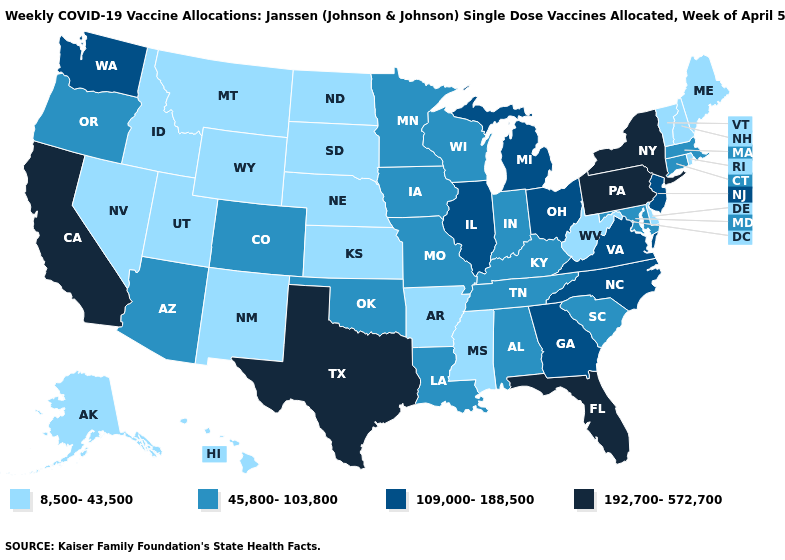Does Oklahoma have the same value as Minnesota?
Concise answer only. Yes. Name the states that have a value in the range 45,800-103,800?
Be succinct. Alabama, Arizona, Colorado, Connecticut, Indiana, Iowa, Kentucky, Louisiana, Maryland, Massachusetts, Minnesota, Missouri, Oklahoma, Oregon, South Carolina, Tennessee, Wisconsin. Among the states that border Arkansas , does Mississippi have the highest value?
Be succinct. No. Name the states that have a value in the range 8,500-43,500?
Answer briefly. Alaska, Arkansas, Delaware, Hawaii, Idaho, Kansas, Maine, Mississippi, Montana, Nebraska, Nevada, New Hampshire, New Mexico, North Dakota, Rhode Island, South Dakota, Utah, Vermont, West Virginia, Wyoming. What is the value of South Carolina?
Answer briefly. 45,800-103,800. Does Illinois have a higher value than Vermont?
Give a very brief answer. Yes. What is the lowest value in the West?
Quick response, please. 8,500-43,500. Which states hav the highest value in the South?
Be succinct. Florida, Texas. Name the states that have a value in the range 45,800-103,800?
Quick response, please. Alabama, Arizona, Colorado, Connecticut, Indiana, Iowa, Kentucky, Louisiana, Maryland, Massachusetts, Minnesota, Missouri, Oklahoma, Oregon, South Carolina, Tennessee, Wisconsin. What is the value of North Carolina?
Quick response, please. 109,000-188,500. What is the lowest value in states that border Florida?
Be succinct. 45,800-103,800. What is the value of Florida?
Write a very short answer. 192,700-572,700. Among the states that border Nevada , does Arizona have the lowest value?
Keep it brief. No. What is the value of Minnesota?
Write a very short answer. 45,800-103,800. Among the states that border Idaho , does Washington have the lowest value?
Quick response, please. No. 